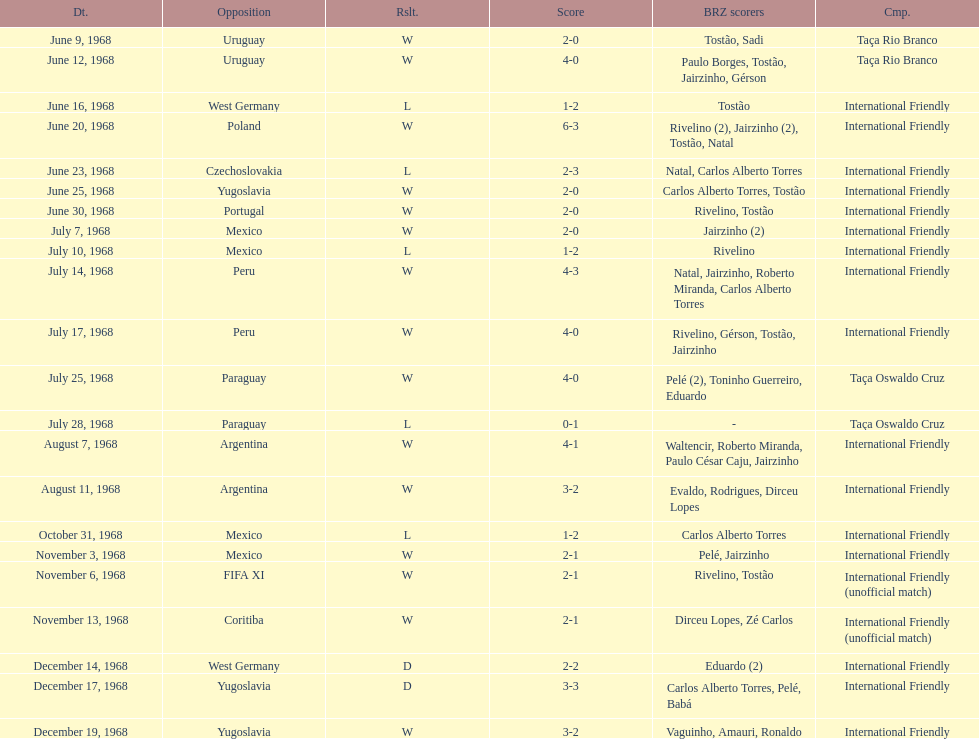Who played brazil previous to the game on june 30th? Yugoslavia. 